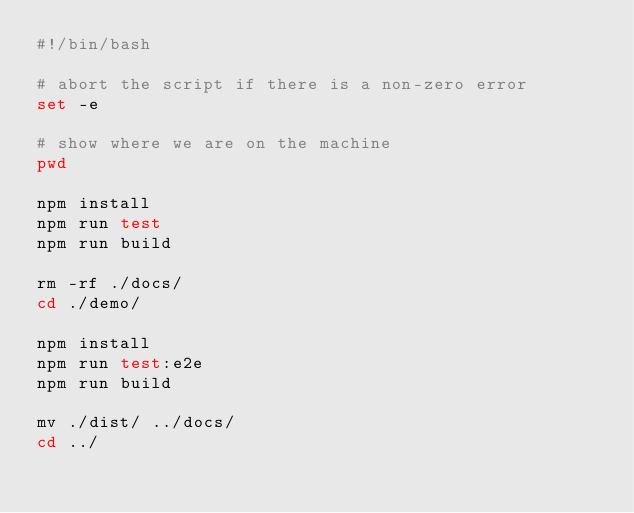<code> <loc_0><loc_0><loc_500><loc_500><_Bash_>#!/bin/bash

# abort the script if there is a non-zero error
set -e

# show where we are on the machine
pwd

npm install
npm run test
npm run build

rm -rf ./docs/
cd ./demo/

npm install
npm run test:e2e
npm run build

mv ./dist/ ../docs/
cd ../</code> 